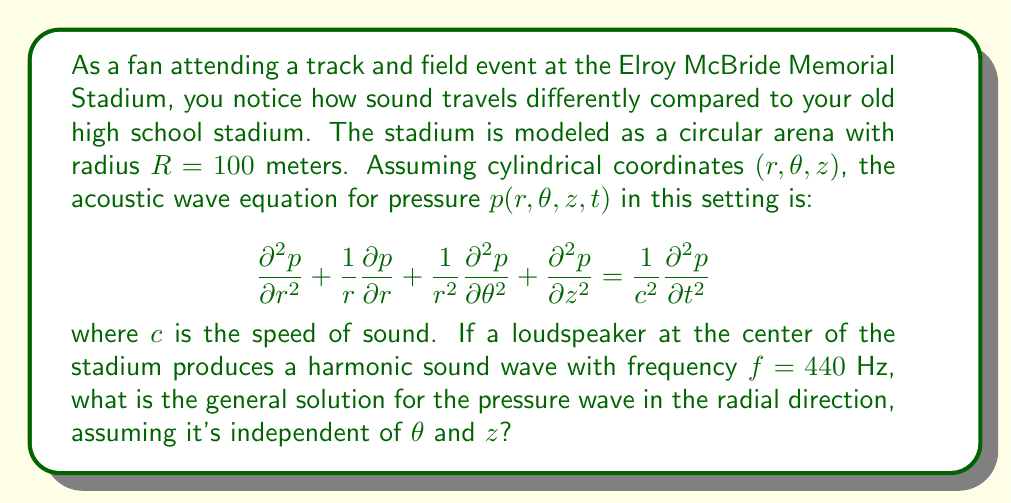Help me with this question. To solve this problem, we'll follow these steps:

1) First, we simplify the acoustic wave equation for our specific case. Since the problem states that the solution is independent of $\theta$ and $z$, we can eliminate those terms:

   $$\frac{\partial^2 p}{\partial r^2} + \frac{1}{r}\frac{\partial p}{\partial r} = \frac{1}{c^2}\frac{\partial^2 p}{\partial t^2}$$

2) We're dealing with a harmonic sound wave, so we can assume a solution of the form:

   $$p(r,t) = R(r)e^{i\omega t}$$

   where $\omega = 2\pi f$ is the angular frequency.

3) Substituting this into our simplified wave equation:

   $$\frac{d^2R}{dr^2} + \frac{1}{r}\frac{dR}{dr} + k^2R = 0$$

   where $k = \frac{\omega}{c} = \frac{2\pi f}{c}$ is the wave number.

4) This is the Bessel equation of order zero. Its general solution is:

   $$R(r) = AJ_0(kr) + BY_0(kr)$$

   where $J_0$ is the Bessel function of the first kind of order zero, and $Y_0$ is the Bessel function of the second kind of order zero. $A$ and $B$ are arbitrary constants.

5) Therefore, the general solution for the pressure wave is:

   $$p(r,t) = [AJ_0(kr) + BY_0(kr)]e^{i\omega t}$$

This solution represents outgoing and incoming cylindrical waves in the stadium.
Answer: The general solution for the pressure wave in the radial direction is:

$$p(r,t) = [AJ_0(kr) + BY_0(kr)]e^{i\omega t}$$

where $J_0$ and $Y_0$ are Bessel functions of the first and second kind of order zero, respectively, $k = \frac{2\pi f}{c}$ is the wave number, and $A$ and $B$ are arbitrary constants. 